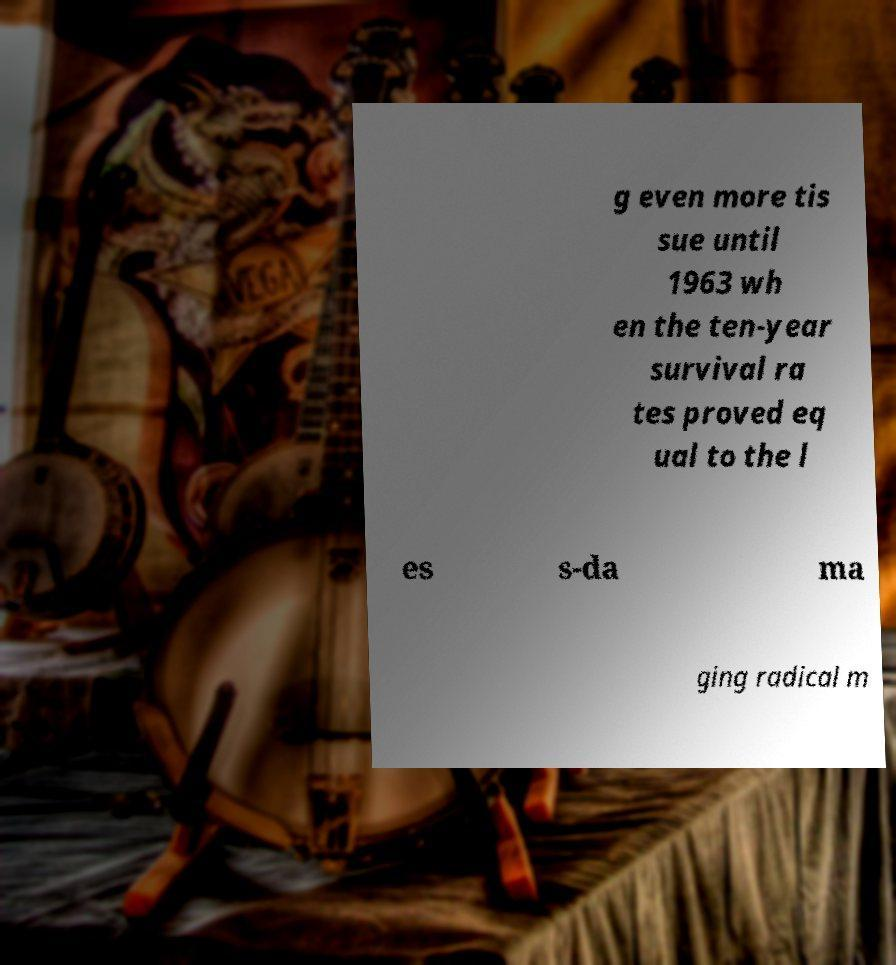For documentation purposes, I need the text within this image transcribed. Could you provide that? g even more tis sue until 1963 wh en the ten-year survival ra tes proved eq ual to the l es s-da ma ging radical m 